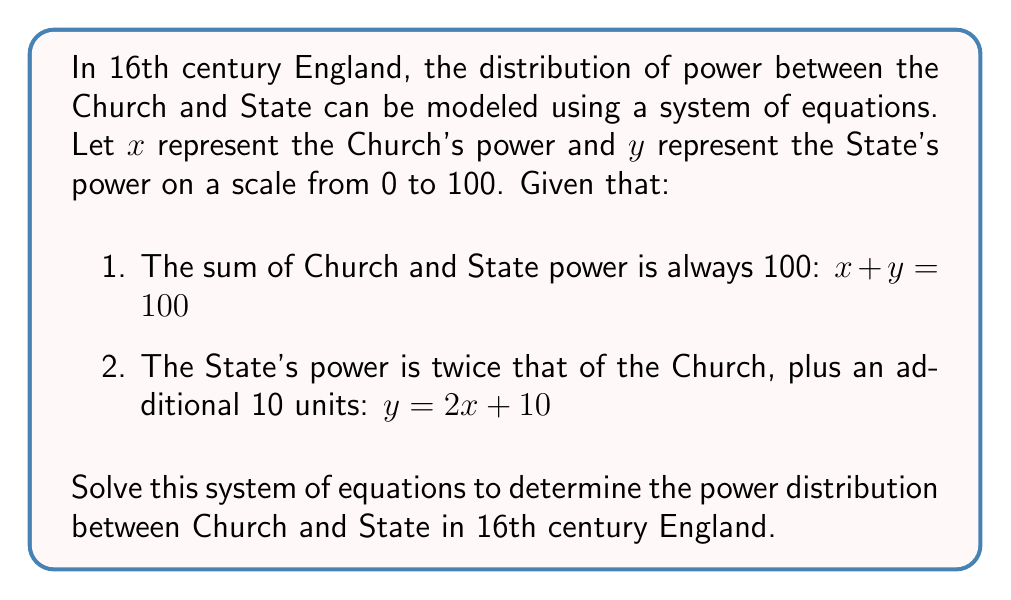Give your solution to this math problem. To solve this system of equations, we'll use the substitution method:

1. We start with two equations:
   $$x + y = 100$$ (Equation 1)
   $$y = 2x + 10$$ (Equation 2)

2. Substitute Equation 2 into Equation 1:
   $$x + (2x + 10) = 100$$

3. Simplify:
   $$x + 2x + 10 = 100$$
   $$3x + 10 = 100$$

4. Subtract 10 from both sides:
   $$3x = 90$$

5. Divide both sides by 3:
   $$x = 30$$

6. Now that we know $x$, we can substitute it back into Equation 2 to find $y$:
   $$y = 2(30) + 10$$
   $$y = 60 + 10$$
   $$y = 70$$

Therefore, the Church's power ($x$) is 30, and the State's power ($y$) is 70.
Answer: Church power: 30, State power: 70 